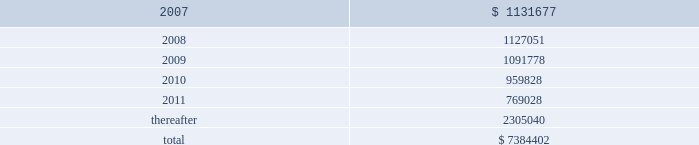American tower corporation and subsidiaries notes to consolidated financial statements 2014 ( continued ) future minimum rental receipts expected from customers under non-cancelable operating lease agreements in effect at december 31 , 2006 are as follows ( in thousands ) : year ending december 31 .
Legal and governmental proceedings related to review of stock option granting practices and related accounting 2014on may 18 , 2006 , the company received a letter of informal inquiry from the sec division of enforcement requesting documents related to company stock option grants and stock option practices .
The inquiry is focused on stock options granted to senior management and members of the company 2019s board of directors during the period 1997 to the present .
The company continues to cooperate with the sec to provide the requested information and documents .
On may 19 , 2006 , the company received a subpoena from the united states attorney 2019s office for the eastern district of new york for records and information relating to its stock option granting practices .
The subpoena requests materials related to certain stock options granted between 1995 and the present .
The company continues to cooperate with the u.s .
Attorney 2019s office to provide the requested information and documents .
On may 26 , 2006 , a securities class action was filed in united states district court for the district of massachusetts against the company and certain of its current officers by john s .
Greenebaum for monetary relief .
Specifically , the complaint names the company , james d .
Taiclet , jr .
And bradley e .
Singer as defendants and alleges that the defendants violated federal securities laws in connection with public statements made relating to the company 2019s stock option practices and related accounting .
The complaint asserts claims under sections 10 ( b ) and 20 ( a ) of the securities exchange act of 1934 , as amended ( exchange act ) and sec rule 10b-5 .
In december 2006 , the court appointed the steamship trade association-international longshoreman 2019s association pension fund as the lead plaintiff .
On may 24 , 2006 and june 14 , 2006 , two shareholder derivative lawsuits were filed in suffolk county superior court in massachusetts by eric johnston and robert l .
Garber , respectively .
The lawsuits were filed against certain of the company 2019s current and former officers and directors for alleged breaches of fiduciary duties and unjust enrichment in connection with the company 2019s stock option granting practices .
The lawsuits also name the company as a nominal defendant .
The lawsuits seek to recover the damages sustained by the company and disgorgement of all profits received with respect to the alleged backdated stock options .
In october 2006 , these two lawsuits were consolidated and transferred to the court 2019s business litigation session .
On june 13 , 2006 , june 22 , 2006 and august 23 , 2006 , three shareholder derivative lawsuits were filed in united states district court for the district of massachusetts by new south wales treasury corporation , as trustee for the alpha international managers trust , frank c .
Kalil and don holland , and leslie cramer , respectively .
The lawsuits were filed against certain of the company 2019s current and former officers and directors for alleged breaches of fiduciary duties , waste of corporate assets , gross mismanagement and unjust enrichment in connection with the company 2019s stock option granting practices .
The lawsuits also name the company as a nominal defendant .
In december 2006 , the court consolidated these three lawsuits and appointed new south wales treasury corporation as the lead plaintiff .
On february 9 , 2007 , the plaintiffs filed a consolidated .
What was the percent of the total future minimum rental receipts expected from customers under non-cancelable that was due in 2008? 
Computations: (1127051 / 7384402)
Answer: 0.15263. 